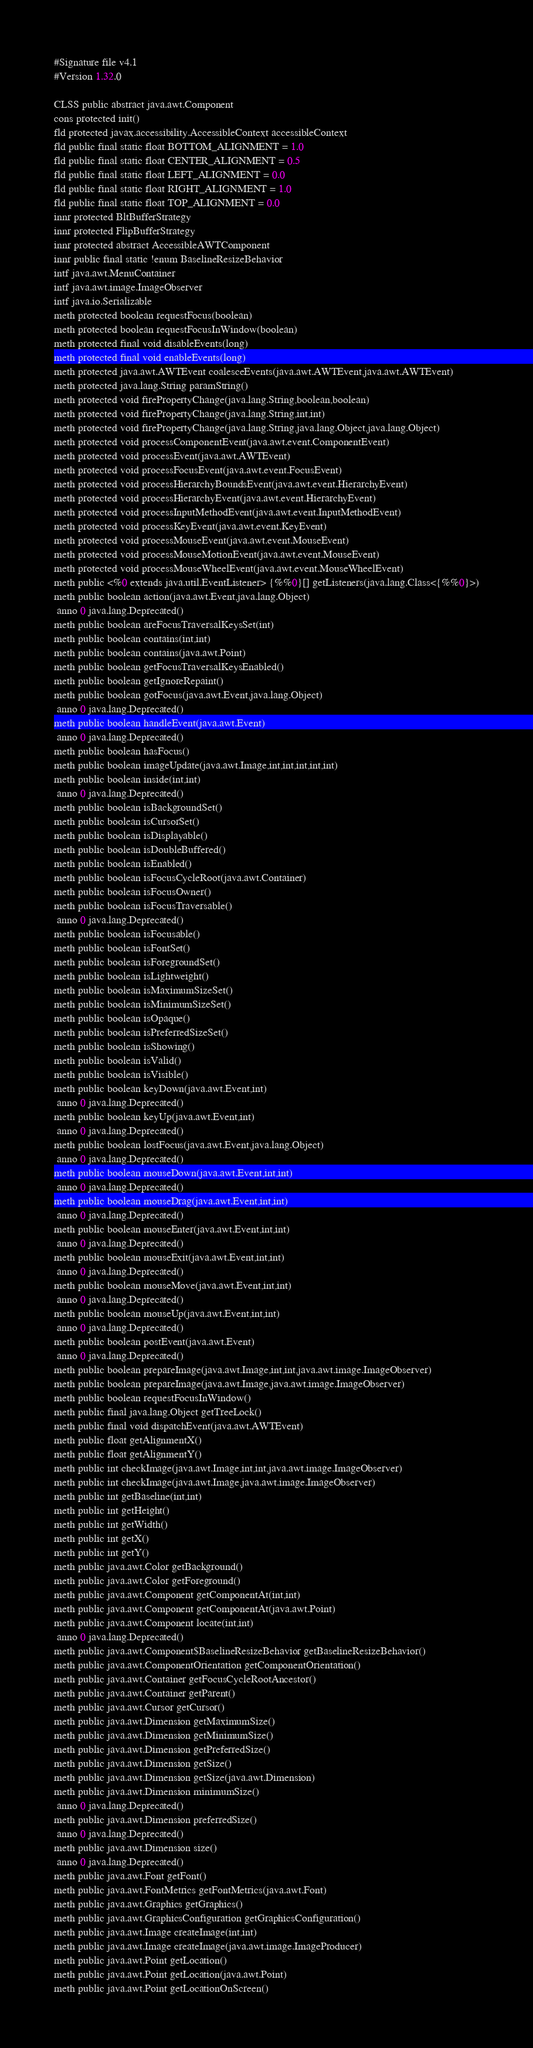Convert code to text. <code><loc_0><loc_0><loc_500><loc_500><_SML_>#Signature file v4.1
#Version 1.32.0

CLSS public abstract java.awt.Component
cons protected init()
fld protected javax.accessibility.AccessibleContext accessibleContext
fld public final static float BOTTOM_ALIGNMENT = 1.0
fld public final static float CENTER_ALIGNMENT = 0.5
fld public final static float LEFT_ALIGNMENT = 0.0
fld public final static float RIGHT_ALIGNMENT = 1.0
fld public final static float TOP_ALIGNMENT = 0.0
innr protected BltBufferStrategy
innr protected FlipBufferStrategy
innr protected abstract AccessibleAWTComponent
innr public final static !enum BaselineResizeBehavior
intf java.awt.MenuContainer
intf java.awt.image.ImageObserver
intf java.io.Serializable
meth protected boolean requestFocus(boolean)
meth protected boolean requestFocusInWindow(boolean)
meth protected final void disableEvents(long)
meth protected final void enableEvents(long)
meth protected java.awt.AWTEvent coalesceEvents(java.awt.AWTEvent,java.awt.AWTEvent)
meth protected java.lang.String paramString()
meth protected void firePropertyChange(java.lang.String,boolean,boolean)
meth protected void firePropertyChange(java.lang.String,int,int)
meth protected void firePropertyChange(java.lang.String,java.lang.Object,java.lang.Object)
meth protected void processComponentEvent(java.awt.event.ComponentEvent)
meth protected void processEvent(java.awt.AWTEvent)
meth protected void processFocusEvent(java.awt.event.FocusEvent)
meth protected void processHierarchyBoundsEvent(java.awt.event.HierarchyEvent)
meth protected void processHierarchyEvent(java.awt.event.HierarchyEvent)
meth protected void processInputMethodEvent(java.awt.event.InputMethodEvent)
meth protected void processKeyEvent(java.awt.event.KeyEvent)
meth protected void processMouseEvent(java.awt.event.MouseEvent)
meth protected void processMouseMotionEvent(java.awt.event.MouseEvent)
meth protected void processMouseWheelEvent(java.awt.event.MouseWheelEvent)
meth public <%0 extends java.util.EventListener> {%%0}[] getListeners(java.lang.Class<{%%0}>)
meth public boolean action(java.awt.Event,java.lang.Object)
 anno 0 java.lang.Deprecated()
meth public boolean areFocusTraversalKeysSet(int)
meth public boolean contains(int,int)
meth public boolean contains(java.awt.Point)
meth public boolean getFocusTraversalKeysEnabled()
meth public boolean getIgnoreRepaint()
meth public boolean gotFocus(java.awt.Event,java.lang.Object)
 anno 0 java.lang.Deprecated()
meth public boolean handleEvent(java.awt.Event)
 anno 0 java.lang.Deprecated()
meth public boolean hasFocus()
meth public boolean imageUpdate(java.awt.Image,int,int,int,int,int)
meth public boolean inside(int,int)
 anno 0 java.lang.Deprecated()
meth public boolean isBackgroundSet()
meth public boolean isCursorSet()
meth public boolean isDisplayable()
meth public boolean isDoubleBuffered()
meth public boolean isEnabled()
meth public boolean isFocusCycleRoot(java.awt.Container)
meth public boolean isFocusOwner()
meth public boolean isFocusTraversable()
 anno 0 java.lang.Deprecated()
meth public boolean isFocusable()
meth public boolean isFontSet()
meth public boolean isForegroundSet()
meth public boolean isLightweight()
meth public boolean isMaximumSizeSet()
meth public boolean isMinimumSizeSet()
meth public boolean isOpaque()
meth public boolean isPreferredSizeSet()
meth public boolean isShowing()
meth public boolean isValid()
meth public boolean isVisible()
meth public boolean keyDown(java.awt.Event,int)
 anno 0 java.lang.Deprecated()
meth public boolean keyUp(java.awt.Event,int)
 anno 0 java.lang.Deprecated()
meth public boolean lostFocus(java.awt.Event,java.lang.Object)
 anno 0 java.lang.Deprecated()
meth public boolean mouseDown(java.awt.Event,int,int)
 anno 0 java.lang.Deprecated()
meth public boolean mouseDrag(java.awt.Event,int,int)
 anno 0 java.lang.Deprecated()
meth public boolean mouseEnter(java.awt.Event,int,int)
 anno 0 java.lang.Deprecated()
meth public boolean mouseExit(java.awt.Event,int,int)
 anno 0 java.lang.Deprecated()
meth public boolean mouseMove(java.awt.Event,int,int)
 anno 0 java.lang.Deprecated()
meth public boolean mouseUp(java.awt.Event,int,int)
 anno 0 java.lang.Deprecated()
meth public boolean postEvent(java.awt.Event)
 anno 0 java.lang.Deprecated()
meth public boolean prepareImage(java.awt.Image,int,int,java.awt.image.ImageObserver)
meth public boolean prepareImage(java.awt.Image,java.awt.image.ImageObserver)
meth public boolean requestFocusInWindow()
meth public final java.lang.Object getTreeLock()
meth public final void dispatchEvent(java.awt.AWTEvent)
meth public float getAlignmentX()
meth public float getAlignmentY()
meth public int checkImage(java.awt.Image,int,int,java.awt.image.ImageObserver)
meth public int checkImage(java.awt.Image,java.awt.image.ImageObserver)
meth public int getBaseline(int,int)
meth public int getHeight()
meth public int getWidth()
meth public int getX()
meth public int getY()
meth public java.awt.Color getBackground()
meth public java.awt.Color getForeground()
meth public java.awt.Component getComponentAt(int,int)
meth public java.awt.Component getComponentAt(java.awt.Point)
meth public java.awt.Component locate(int,int)
 anno 0 java.lang.Deprecated()
meth public java.awt.Component$BaselineResizeBehavior getBaselineResizeBehavior()
meth public java.awt.ComponentOrientation getComponentOrientation()
meth public java.awt.Container getFocusCycleRootAncestor()
meth public java.awt.Container getParent()
meth public java.awt.Cursor getCursor()
meth public java.awt.Dimension getMaximumSize()
meth public java.awt.Dimension getMinimumSize()
meth public java.awt.Dimension getPreferredSize()
meth public java.awt.Dimension getSize()
meth public java.awt.Dimension getSize(java.awt.Dimension)
meth public java.awt.Dimension minimumSize()
 anno 0 java.lang.Deprecated()
meth public java.awt.Dimension preferredSize()
 anno 0 java.lang.Deprecated()
meth public java.awt.Dimension size()
 anno 0 java.lang.Deprecated()
meth public java.awt.Font getFont()
meth public java.awt.FontMetrics getFontMetrics(java.awt.Font)
meth public java.awt.Graphics getGraphics()
meth public java.awt.GraphicsConfiguration getGraphicsConfiguration()
meth public java.awt.Image createImage(int,int)
meth public java.awt.Image createImage(java.awt.image.ImageProducer)
meth public java.awt.Point getLocation()
meth public java.awt.Point getLocation(java.awt.Point)
meth public java.awt.Point getLocationOnScreen()</code> 